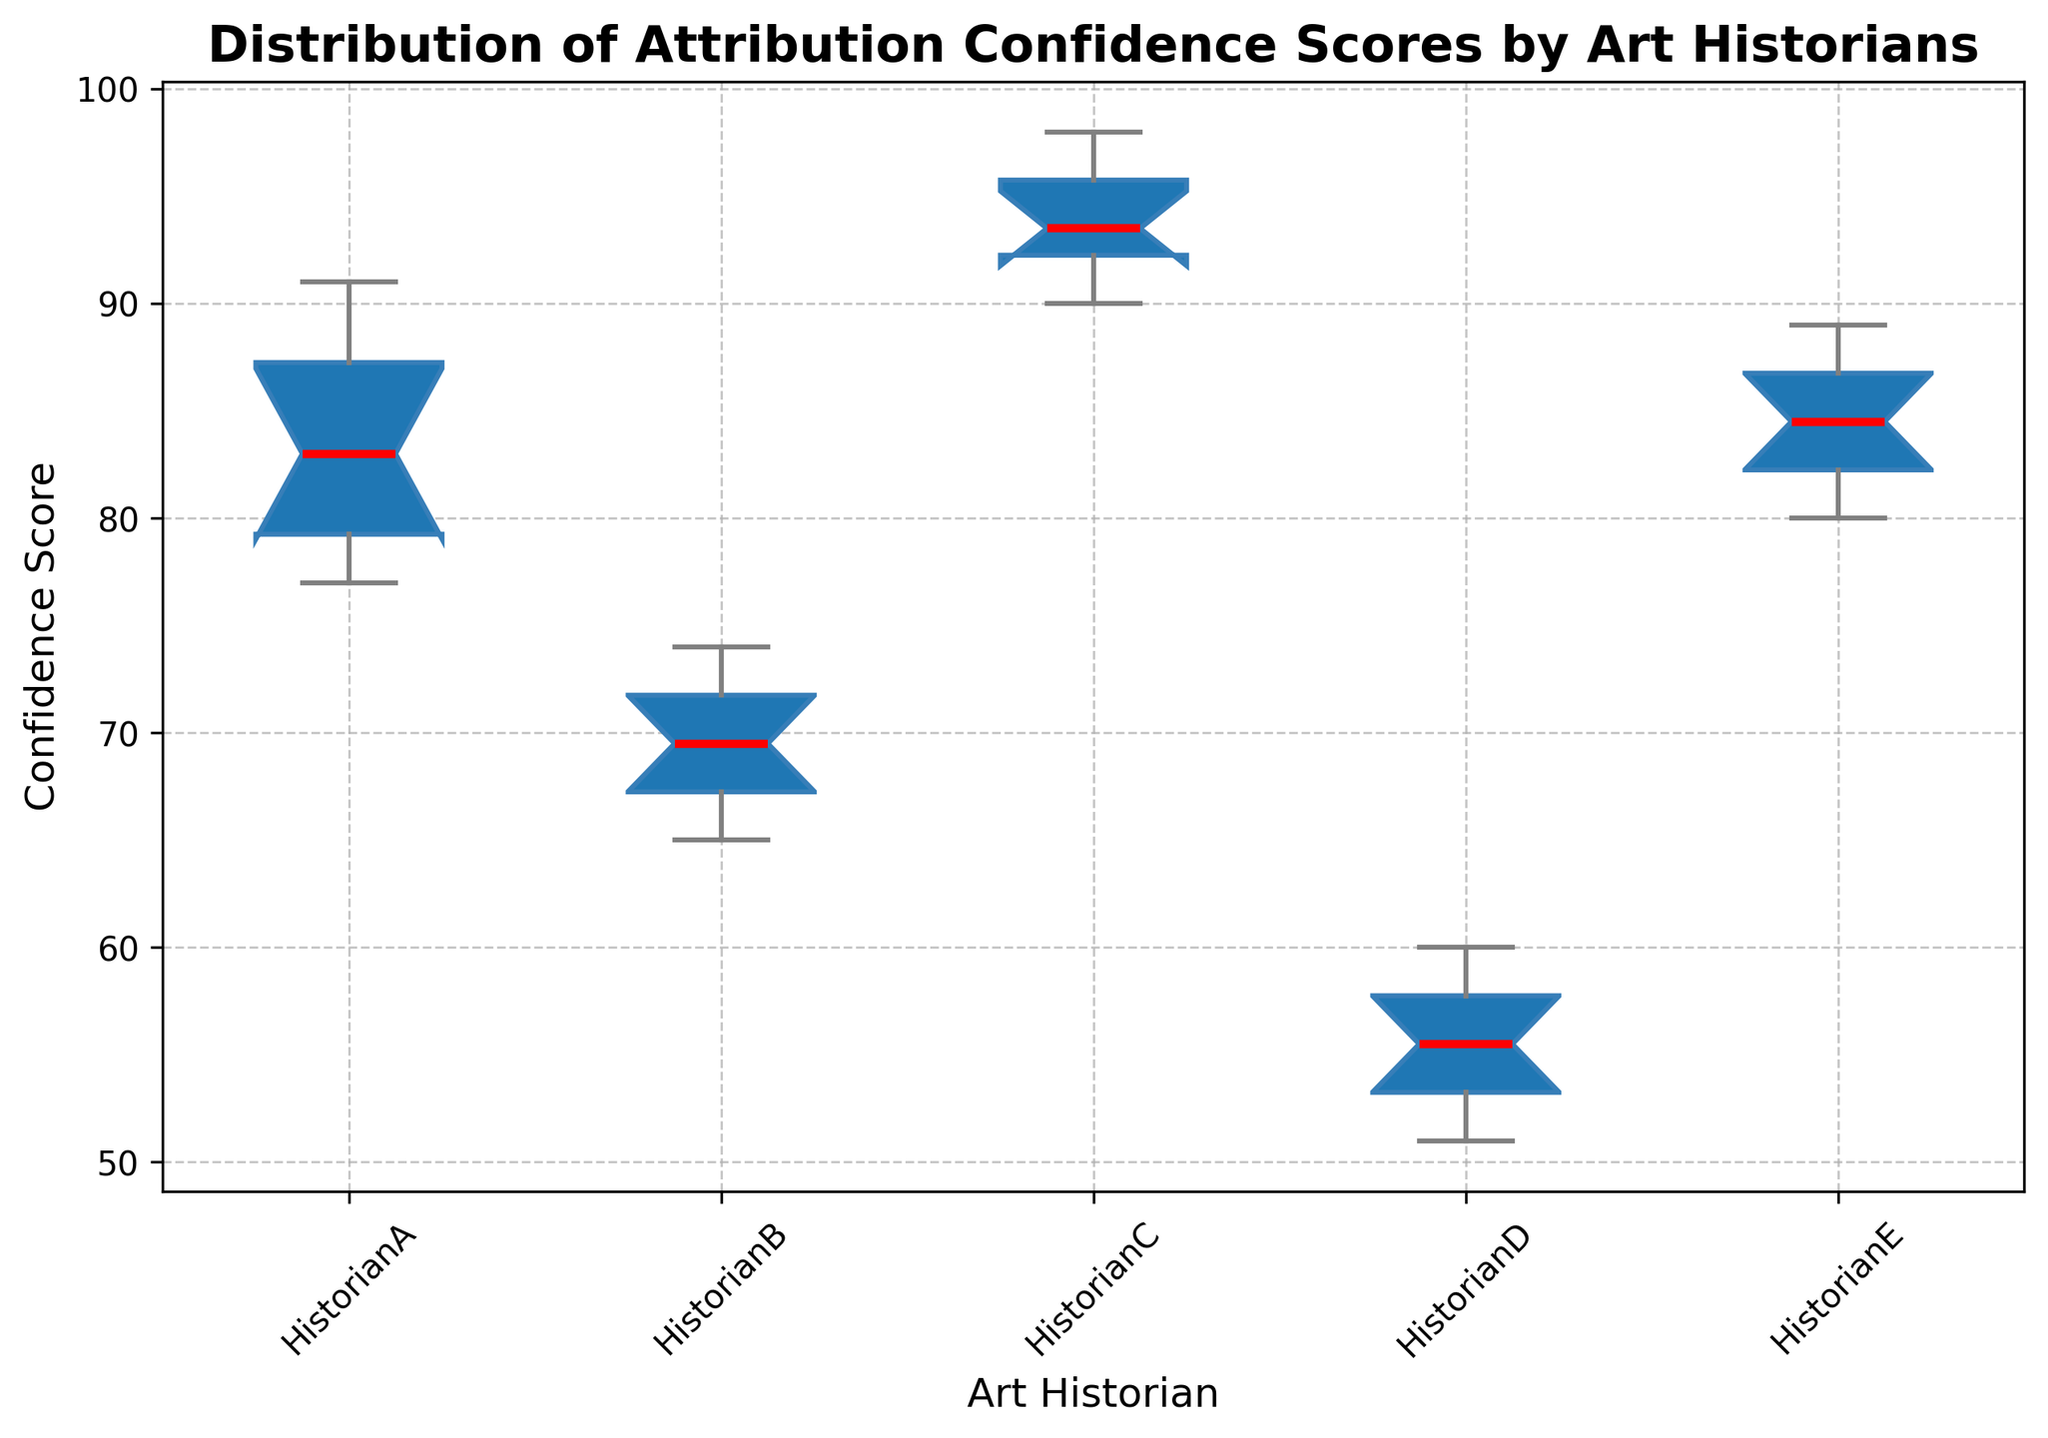What's the median value of the confidence scores for Historian A? The median is the middle value of the ordered list. For Historian A, the ordered confidence scores are [77, 78, 79, 80, 82, 84, 85, 88, 90, 91]. The median is the average of the 5th and 6th values (82 and 84). So, (82 + 84) / 2 = 83.
Answer: 83 Which historian has the highest median confidence score? By observing the box plots, the median is indicated by the red line inside each box. Historian C has the highest median since their red line is at the highest position compared to the other historians.
Answer: Historian C How do the interquartile ranges of Historian B and Historian D compare? The interquartile range (IQR) is the distance between the lower quartile (Q1) and the upper quartile (Q3). Visually comparing the heights of the boxes shows that Historian B has a narrower IQR compared to Historian D.
Answer: Historian B has a narrower IQR than Historian D What's the interquartile range (IQR) of confidence scores for Historian B? The IQR is the difference between the upper quartile (Q3) and the lower quartile (Q1). For Historian B, Q1 is around 66, and Q3 is around 73. Thus, the IQR is 73 - 66 = 7.
Answer: 7 Which historian has the widest spread in confidence scores? The spread can be visually estimated by the distance between the lowest whisker and the highest whisker. Historian C has the widest spread as the whiskers span the widest range of scores.
Answer: Historian C Are there any outliers in the confidence scores for Historian E? Outliers are typically represented by dots outside the whiskers in a box plot. For Historian E, there are no dots outside the whiskers, indicating no outliers.
Answer: No What is the range of confidence scores for Historian D? The range is the difference between the maximum and minimum values. For Historian D, the minimum is 51 (lowest whisker) and the maximum is 60 (highest whisker). Thus, the range is 60 - 51 = 9.
Answer: 9 Which historian has the lowest median confidence score? The median is indicated by the red line inside each box plot. Historian D has the lowest median as their red line is at the lowest position compared to the other historians.
Answer: Historian D Compare the interquartile ranges (IQRs) of Historian A and Historian E. Which is greater? By examining the heights of the boxes, Historian A has a slightly taller box compared to Historian E, indicating a greater IQR.
Answer: Historian A What's the mean confidence score for Historian C? The mean is the total sum of scores divided by the number of scores. Adding Historian C's scores (95 + 93 + 98 + 90 + 96 + 94 + 92 + 97 + 93 + 91) gives 939, and dividing by 10 gives 93.9.
Answer: 93.9 